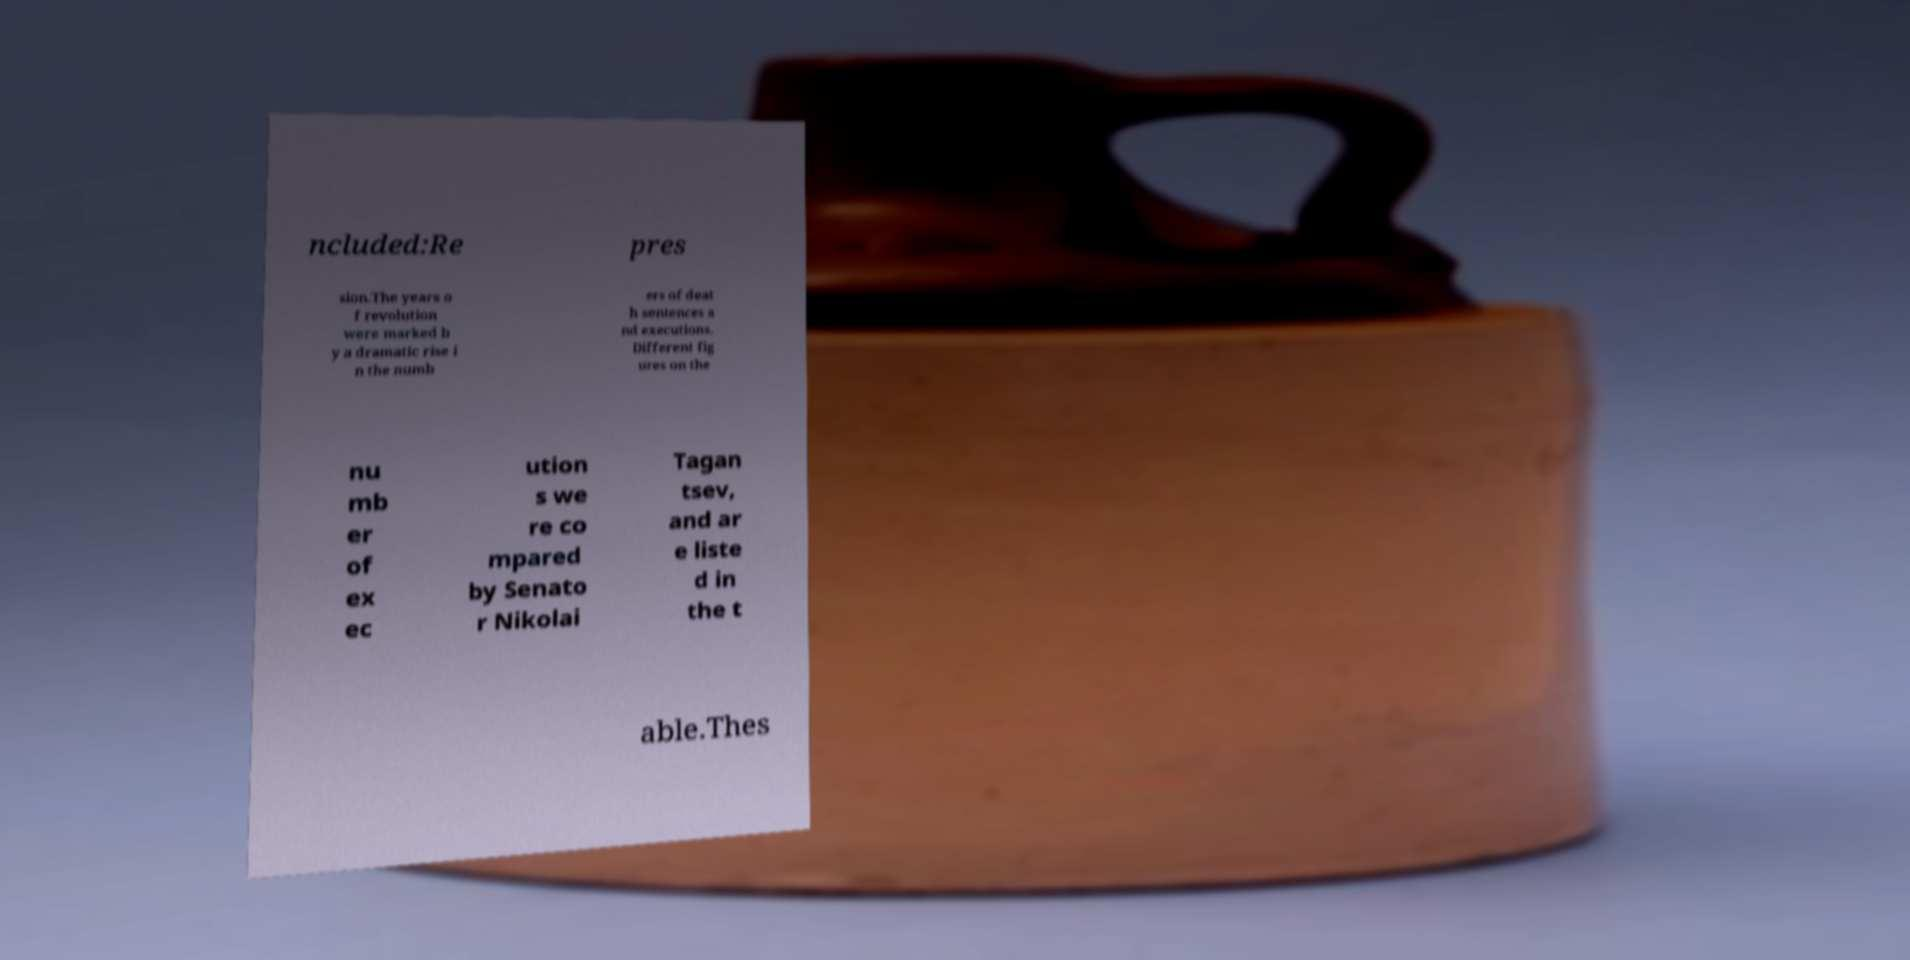Can you accurately transcribe the text from the provided image for me? ncluded:Re pres sion.The years o f revolution were marked b y a dramatic rise i n the numb ers of deat h sentences a nd executions. Different fig ures on the nu mb er of ex ec ution s we re co mpared by Senato r Nikolai Tagan tsev, and ar e liste d in the t able.Thes 